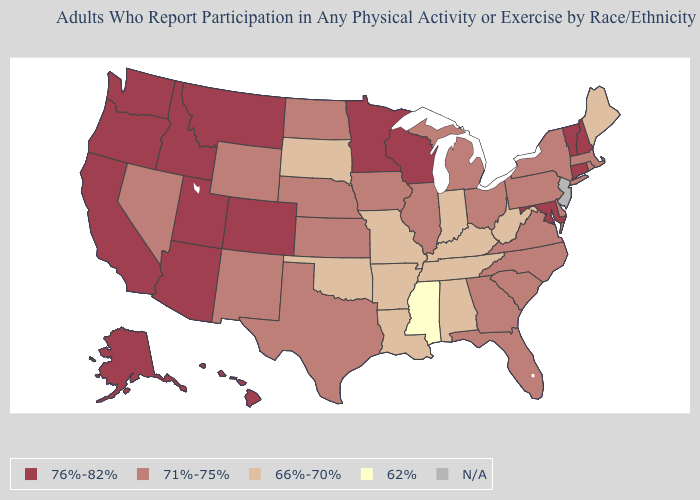Name the states that have a value in the range 76%-82%?
Write a very short answer. Alaska, Arizona, California, Colorado, Connecticut, Hawaii, Idaho, Maryland, Minnesota, Montana, New Hampshire, Oregon, Utah, Vermont, Washington, Wisconsin. What is the value of North Carolina?
Keep it brief. 71%-75%. What is the value of Tennessee?
Be succinct. 66%-70%. Name the states that have a value in the range 71%-75%?
Be succinct. Delaware, Florida, Georgia, Illinois, Iowa, Kansas, Massachusetts, Michigan, Nebraska, Nevada, New Mexico, New York, North Carolina, North Dakota, Ohio, Pennsylvania, Rhode Island, South Carolina, Texas, Virginia, Wyoming. Is the legend a continuous bar?
Answer briefly. No. Name the states that have a value in the range N/A?
Be succinct. New Jersey. Which states have the highest value in the USA?
Be succinct. Alaska, Arizona, California, Colorado, Connecticut, Hawaii, Idaho, Maryland, Minnesota, Montana, New Hampshire, Oregon, Utah, Vermont, Washington, Wisconsin. How many symbols are there in the legend?
Write a very short answer. 5. What is the highest value in the South ?
Short answer required. 76%-82%. Does the first symbol in the legend represent the smallest category?
Answer briefly. No. Which states have the highest value in the USA?
Be succinct. Alaska, Arizona, California, Colorado, Connecticut, Hawaii, Idaho, Maryland, Minnesota, Montana, New Hampshire, Oregon, Utah, Vermont, Washington, Wisconsin. Which states have the lowest value in the South?
Give a very brief answer. Mississippi. What is the value of Idaho?
Short answer required. 76%-82%. Does Maine have the lowest value in the Northeast?
Concise answer only. Yes. 